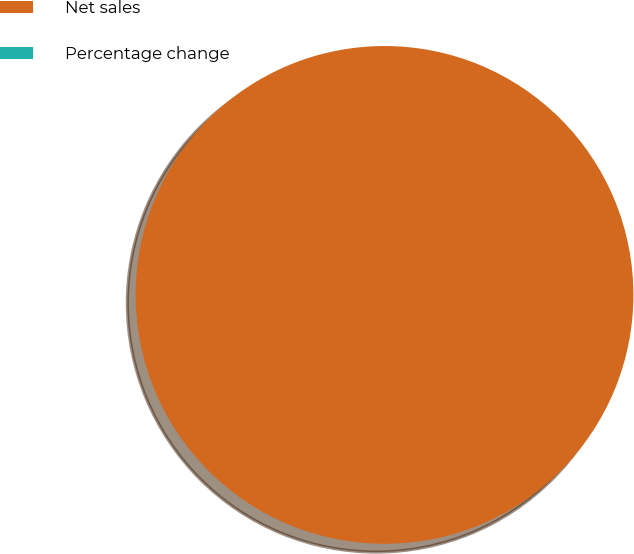Convert chart to OTSL. <chart><loc_0><loc_0><loc_500><loc_500><pie_chart><fcel>Net sales<fcel>Percentage change<nl><fcel>100.0%<fcel>0.0%<nl></chart> 